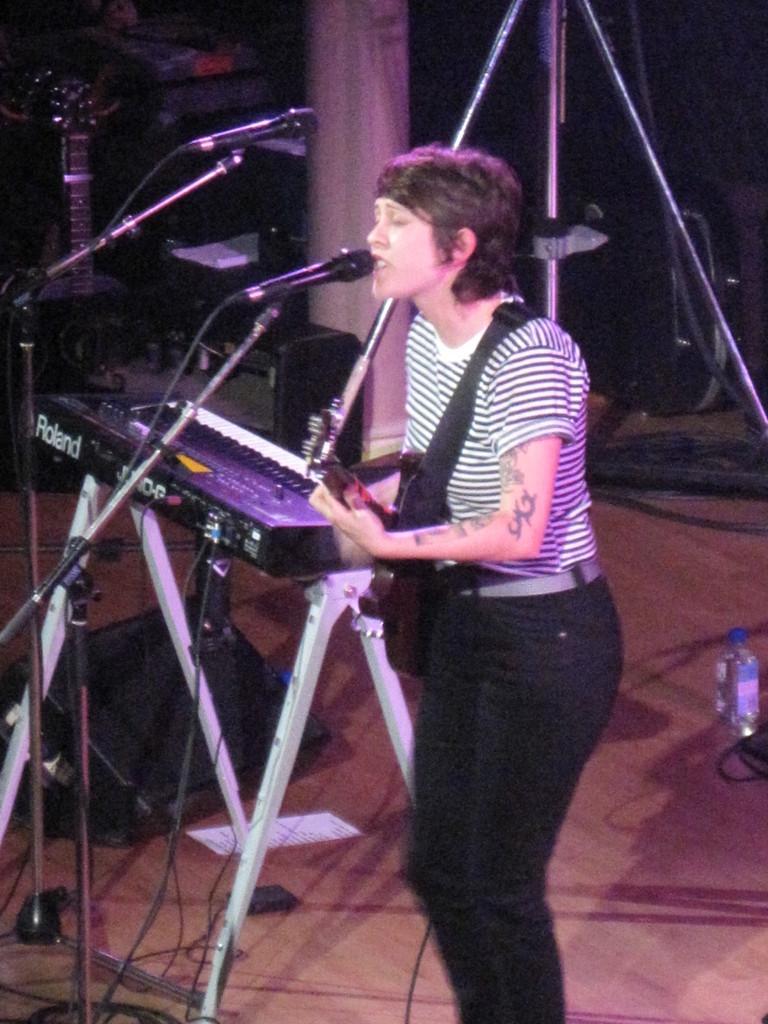Describe this image in one or two sentences. In this image there is a woman singing song in front of a mic, in her hands the is a guitar, beside her their is a piano, in the background there are some musical instruments. 